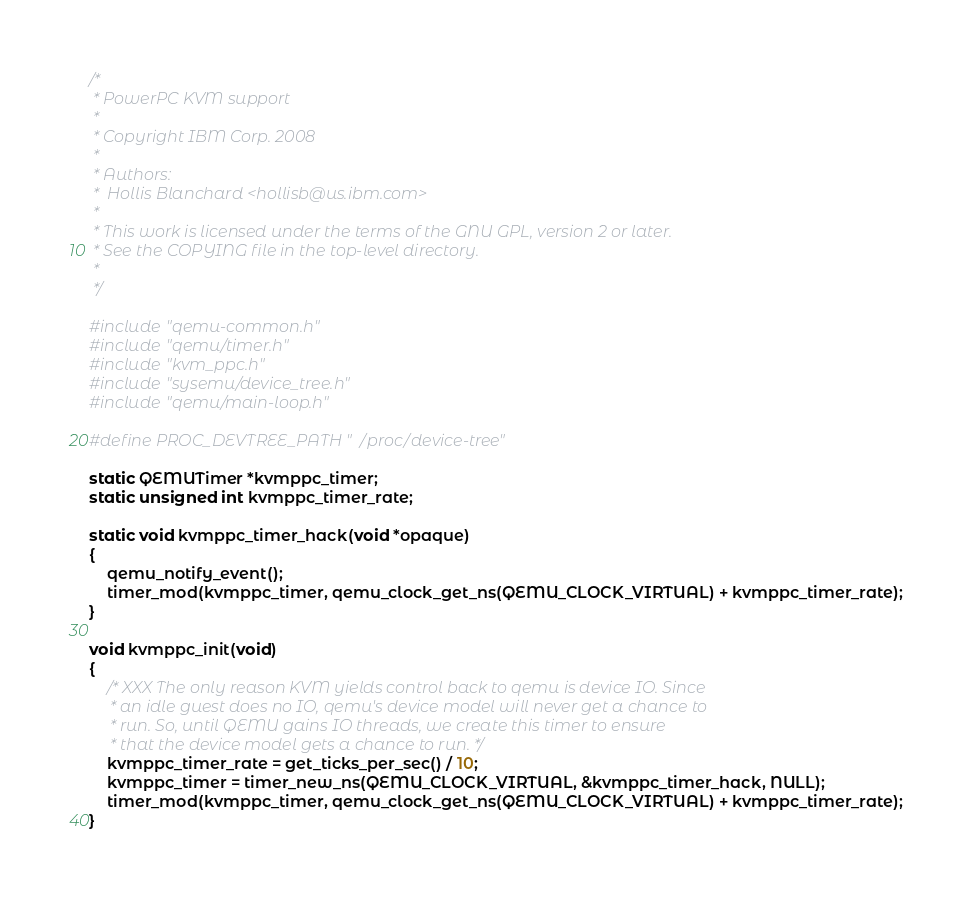Convert code to text. <code><loc_0><loc_0><loc_500><loc_500><_C_>/*
 * PowerPC KVM support
 *
 * Copyright IBM Corp. 2008
 *
 * Authors:
 *  Hollis Blanchard <hollisb@us.ibm.com>
 *
 * This work is licensed under the terms of the GNU GPL, version 2 or later.
 * See the COPYING file in the top-level directory.
 *
 */

#include "qemu-common.h"
#include "qemu/timer.h"
#include "kvm_ppc.h"
#include "sysemu/device_tree.h"
#include "qemu/main-loop.h"

#define PROC_DEVTREE_PATH "/proc/device-tree"

static QEMUTimer *kvmppc_timer;
static unsigned int kvmppc_timer_rate;

static void kvmppc_timer_hack(void *opaque)
{
    qemu_notify_event();
    timer_mod(kvmppc_timer, qemu_clock_get_ns(QEMU_CLOCK_VIRTUAL) + kvmppc_timer_rate);
}

void kvmppc_init(void)
{
    /* XXX The only reason KVM yields control back to qemu is device IO. Since
     * an idle guest does no IO, qemu's device model will never get a chance to
     * run. So, until QEMU gains IO threads, we create this timer to ensure
     * that the device model gets a chance to run. */
    kvmppc_timer_rate = get_ticks_per_sec() / 10;
    kvmppc_timer = timer_new_ns(QEMU_CLOCK_VIRTUAL, &kvmppc_timer_hack, NULL);
    timer_mod(kvmppc_timer, qemu_clock_get_ns(QEMU_CLOCK_VIRTUAL) + kvmppc_timer_rate);
}

</code> 